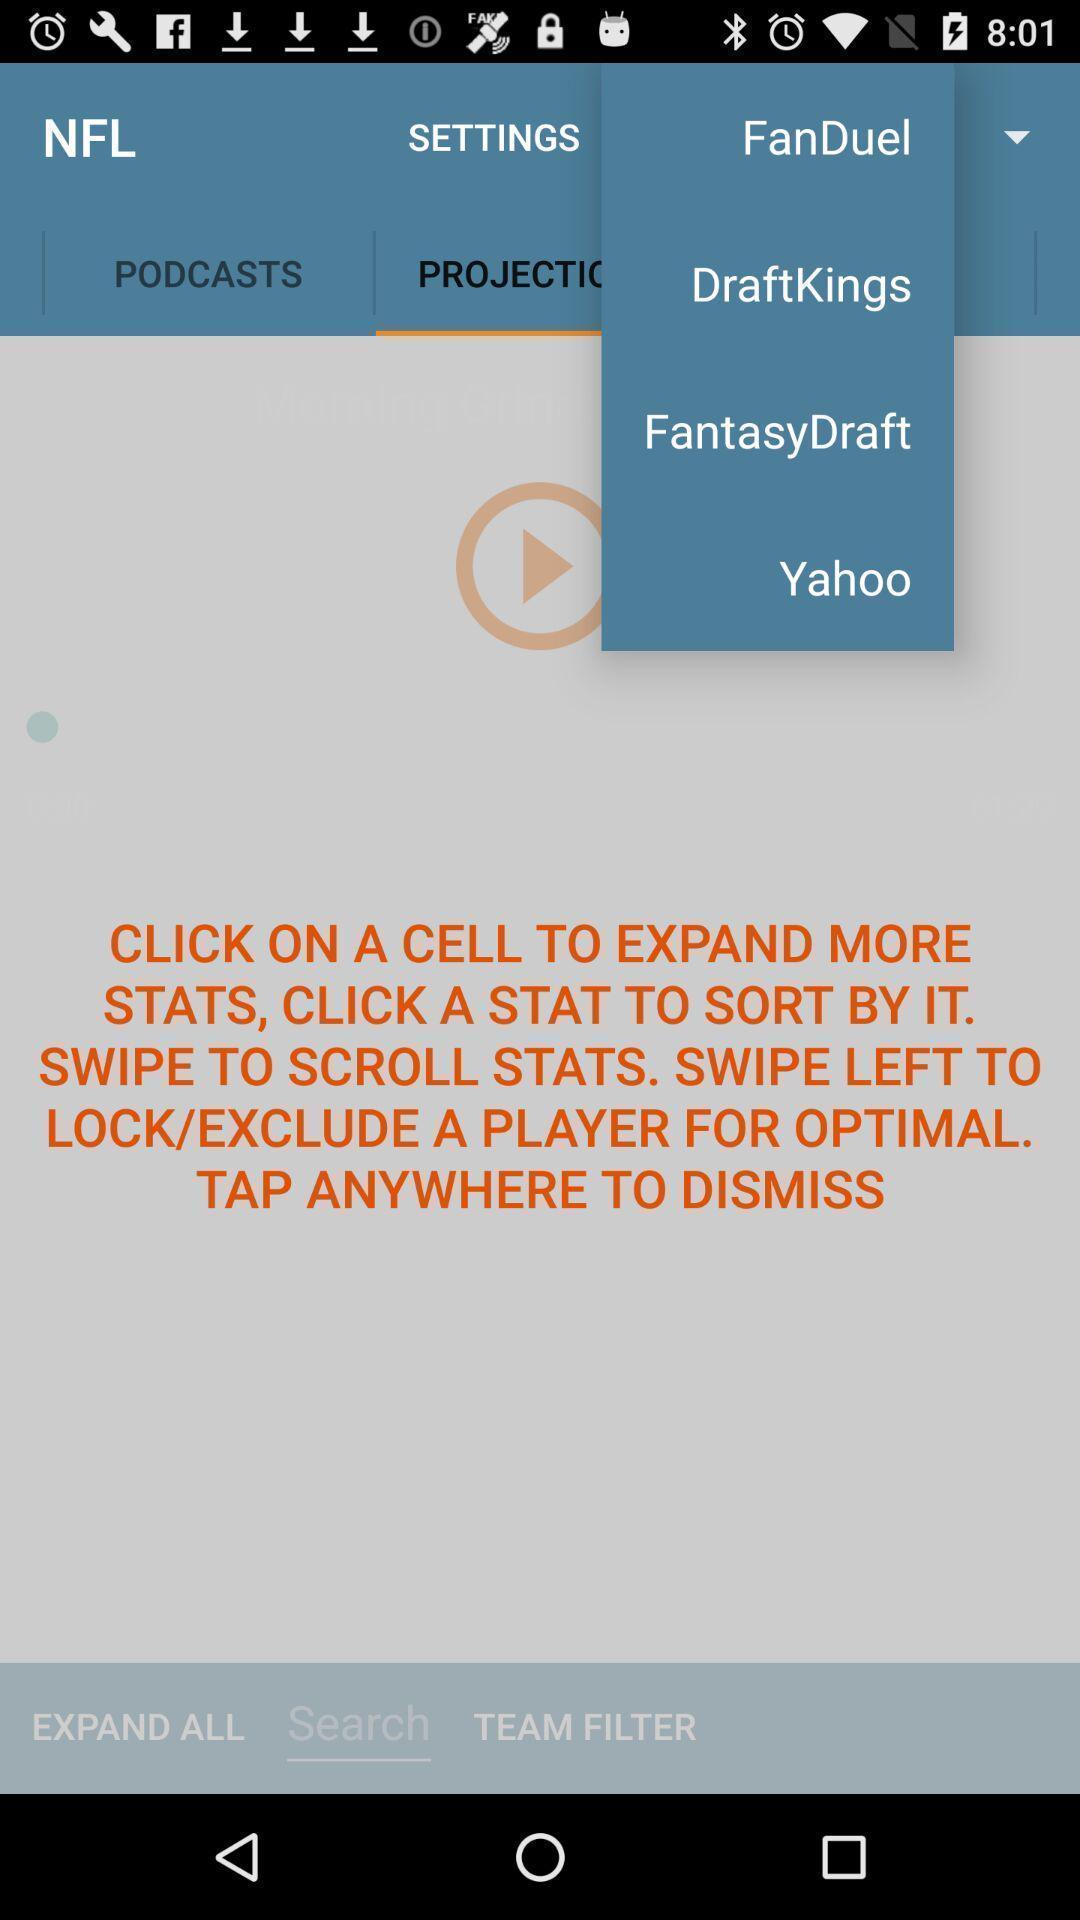Describe the visual elements of this screenshot. Pop up notification of a list. 